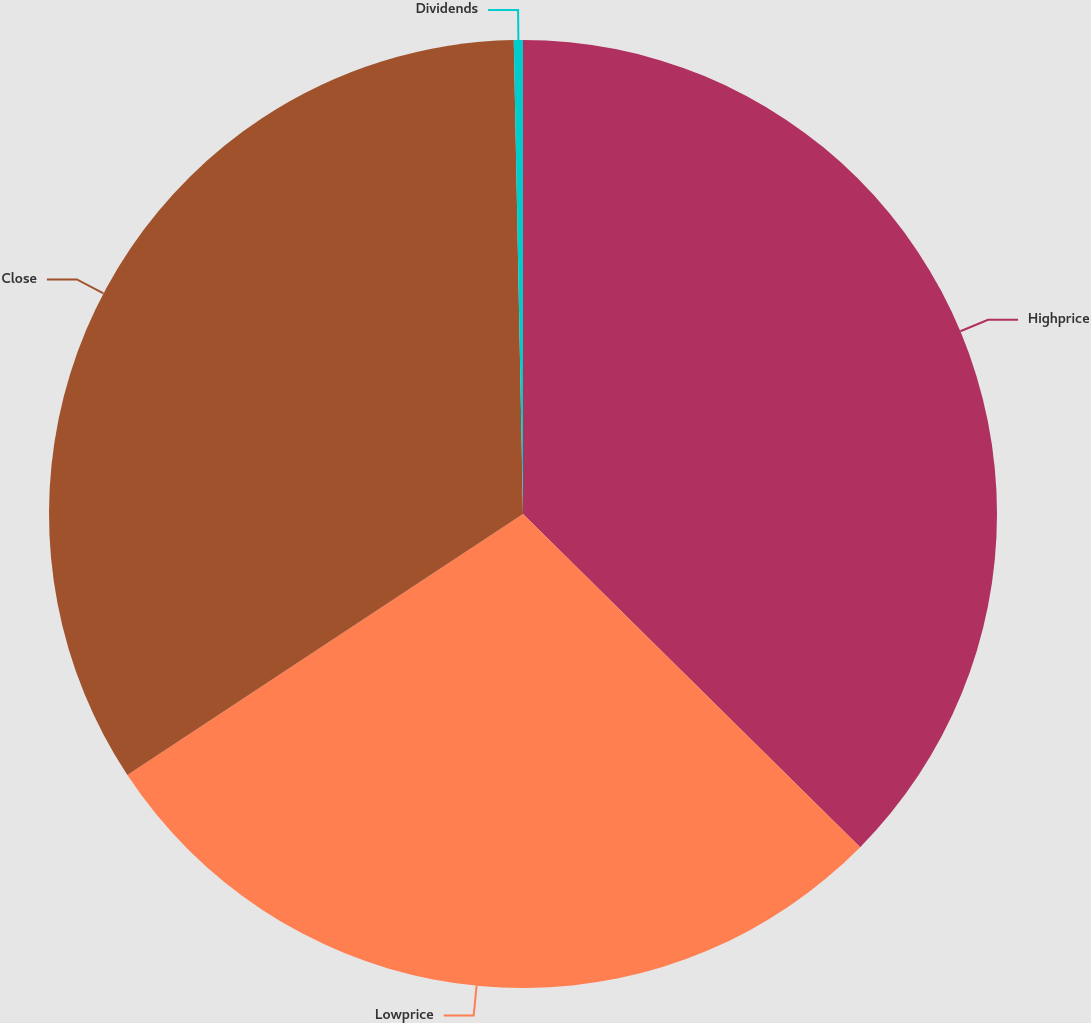Convert chart. <chart><loc_0><loc_0><loc_500><loc_500><pie_chart><fcel>Highprice<fcel>Lowprice<fcel>Close<fcel>Dividends<nl><fcel>37.4%<fcel>28.31%<fcel>33.97%<fcel>0.31%<nl></chart> 